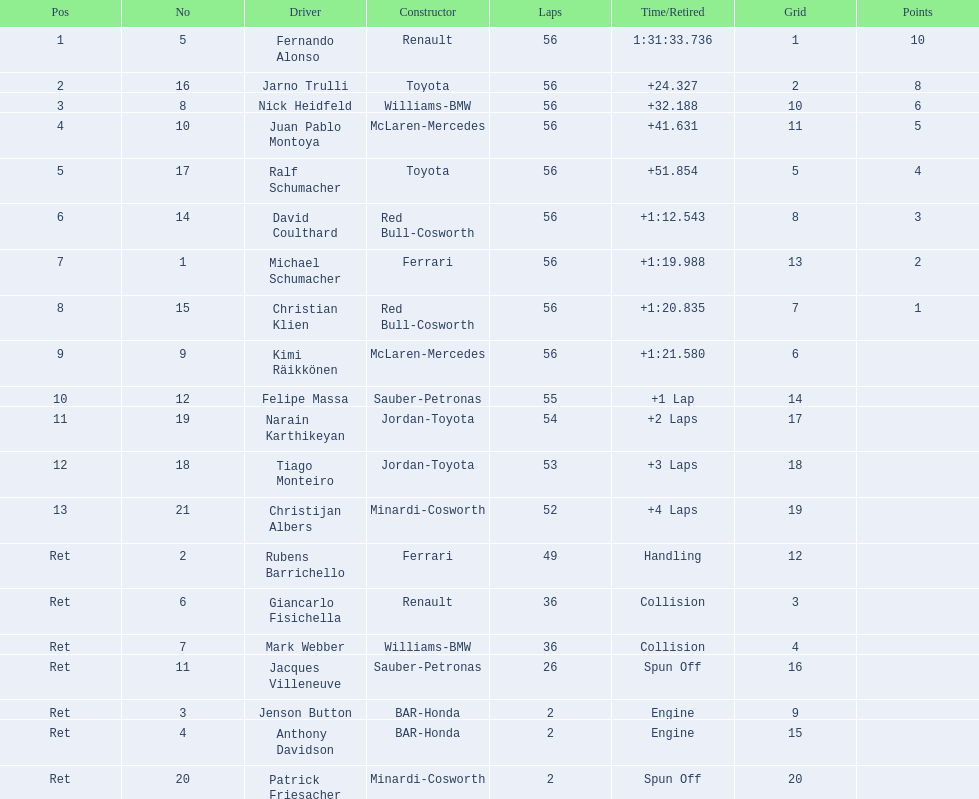How many drivers were retired before the race could end? 7. 